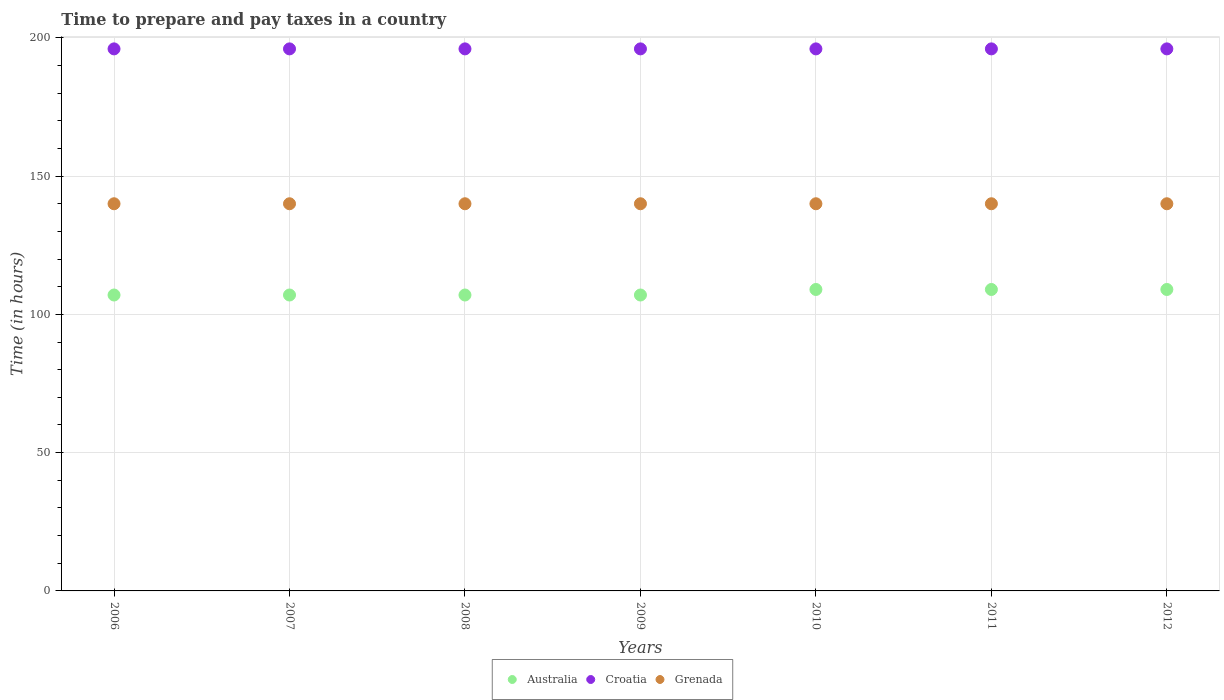How many different coloured dotlines are there?
Your response must be concise. 3. Is the number of dotlines equal to the number of legend labels?
Offer a terse response. Yes. What is the number of hours required to prepare and pay taxes in Australia in 2009?
Offer a terse response. 107. Across all years, what is the maximum number of hours required to prepare and pay taxes in Croatia?
Ensure brevity in your answer.  196. Across all years, what is the minimum number of hours required to prepare and pay taxes in Australia?
Make the answer very short. 107. What is the total number of hours required to prepare and pay taxes in Croatia in the graph?
Your answer should be compact. 1372. What is the difference between the number of hours required to prepare and pay taxes in Grenada in 2006 and that in 2009?
Offer a very short reply. 0. What is the difference between the number of hours required to prepare and pay taxes in Grenada in 2008 and the number of hours required to prepare and pay taxes in Croatia in 2009?
Provide a succinct answer. -56. What is the average number of hours required to prepare and pay taxes in Croatia per year?
Offer a very short reply. 196. In the year 2007, what is the difference between the number of hours required to prepare and pay taxes in Australia and number of hours required to prepare and pay taxes in Grenada?
Provide a succinct answer. -33. What is the ratio of the number of hours required to prepare and pay taxes in Australia in 2010 to that in 2011?
Your response must be concise. 1. Is the number of hours required to prepare and pay taxes in Grenada in 2009 less than that in 2011?
Ensure brevity in your answer.  No. What is the difference between the highest and the second highest number of hours required to prepare and pay taxes in Croatia?
Give a very brief answer. 0. What is the difference between the highest and the lowest number of hours required to prepare and pay taxes in Grenada?
Provide a short and direct response. 0. Does the number of hours required to prepare and pay taxes in Australia monotonically increase over the years?
Your answer should be very brief. No. Is the number of hours required to prepare and pay taxes in Croatia strictly greater than the number of hours required to prepare and pay taxes in Australia over the years?
Your answer should be very brief. Yes. How many years are there in the graph?
Your answer should be compact. 7. What is the difference between two consecutive major ticks on the Y-axis?
Offer a terse response. 50. Does the graph contain any zero values?
Provide a succinct answer. No. How many legend labels are there?
Your answer should be very brief. 3. How are the legend labels stacked?
Provide a succinct answer. Horizontal. What is the title of the graph?
Make the answer very short. Time to prepare and pay taxes in a country. What is the label or title of the Y-axis?
Make the answer very short. Time (in hours). What is the Time (in hours) in Australia in 2006?
Provide a short and direct response. 107. What is the Time (in hours) of Croatia in 2006?
Your answer should be very brief. 196. What is the Time (in hours) in Grenada in 2006?
Offer a terse response. 140. What is the Time (in hours) in Australia in 2007?
Offer a very short reply. 107. What is the Time (in hours) in Croatia in 2007?
Ensure brevity in your answer.  196. What is the Time (in hours) in Grenada in 2007?
Provide a short and direct response. 140. What is the Time (in hours) in Australia in 2008?
Keep it short and to the point. 107. What is the Time (in hours) in Croatia in 2008?
Your answer should be compact. 196. What is the Time (in hours) in Grenada in 2008?
Provide a short and direct response. 140. What is the Time (in hours) in Australia in 2009?
Make the answer very short. 107. What is the Time (in hours) in Croatia in 2009?
Offer a terse response. 196. What is the Time (in hours) of Grenada in 2009?
Give a very brief answer. 140. What is the Time (in hours) in Australia in 2010?
Give a very brief answer. 109. What is the Time (in hours) of Croatia in 2010?
Your response must be concise. 196. What is the Time (in hours) of Grenada in 2010?
Ensure brevity in your answer.  140. What is the Time (in hours) of Australia in 2011?
Provide a short and direct response. 109. What is the Time (in hours) in Croatia in 2011?
Your answer should be compact. 196. What is the Time (in hours) in Grenada in 2011?
Ensure brevity in your answer.  140. What is the Time (in hours) of Australia in 2012?
Your answer should be very brief. 109. What is the Time (in hours) of Croatia in 2012?
Your response must be concise. 196. What is the Time (in hours) of Grenada in 2012?
Provide a succinct answer. 140. Across all years, what is the maximum Time (in hours) of Australia?
Your answer should be compact. 109. Across all years, what is the maximum Time (in hours) of Croatia?
Your answer should be compact. 196. Across all years, what is the maximum Time (in hours) in Grenada?
Your response must be concise. 140. Across all years, what is the minimum Time (in hours) of Australia?
Your answer should be very brief. 107. Across all years, what is the minimum Time (in hours) in Croatia?
Provide a short and direct response. 196. Across all years, what is the minimum Time (in hours) of Grenada?
Your response must be concise. 140. What is the total Time (in hours) in Australia in the graph?
Keep it short and to the point. 755. What is the total Time (in hours) of Croatia in the graph?
Ensure brevity in your answer.  1372. What is the total Time (in hours) in Grenada in the graph?
Keep it short and to the point. 980. What is the difference between the Time (in hours) of Australia in 2006 and that in 2007?
Offer a terse response. 0. What is the difference between the Time (in hours) in Australia in 2006 and that in 2008?
Your answer should be very brief. 0. What is the difference between the Time (in hours) of Grenada in 2006 and that in 2008?
Ensure brevity in your answer.  0. What is the difference between the Time (in hours) of Australia in 2006 and that in 2009?
Give a very brief answer. 0. What is the difference between the Time (in hours) in Croatia in 2006 and that in 2009?
Your answer should be compact. 0. What is the difference between the Time (in hours) in Croatia in 2006 and that in 2010?
Make the answer very short. 0. What is the difference between the Time (in hours) in Grenada in 2006 and that in 2010?
Keep it short and to the point. 0. What is the difference between the Time (in hours) of Croatia in 2006 and that in 2011?
Your response must be concise. 0. What is the difference between the Time (in hours) in Australia in 2006 and that in 2012?
Make the answer very short. -2. What is the difference between the Time (in hours) of Grenada in 2006 and that in 2012?
Keep it short and to the point. 0. What is the difference between the Time (in hours) in Grenada in 2007 and that in 2008?
Your answer should be compact. 0. What is the difference between the Time (in hours) in Australia in 2007 and that in 2009?
Your answer should be compact. 0. What is the difference between the Time (in hours) of Croatia in 2007 and that in 2009?
Give a very brief answer. 0. What is the difference between the Time (in hours) of Grenada in 2007 and that in 2009?
Offer a terse response. 0. What is the difference between the Time (in hours) of Australia in 2007 and that in 2011?
Your answer should be compact. -2. What is the difference between the Time (in hours) in Grenada in 2007 and that in 2011?
Give a very brief answer. 0. What is the difference between the Time (in hours) in Australia in 2007 and that in 2012?
Give a very brief answer. -2. What is the difference between the Time (in hours) in Australia in 2008 and that in 2009?
Provide a short and direct response. 0. What is the difference between the Time (in hours) in Australia in 2008 and that in 2010?
Your answer should be very brief. -2. What is the difference between the Time (in hours) in Grenada in 2008 and that in 2010?
Your response must be concise. 0. What is the difference between the Time (in hours) of Grenada in 2008 and that in 2011?
Provide a succinct answer. 0. What is the difference between the Time (in hours) in Australia in 2008 and that in 2012?
Give a very brief answer. -2. What is the difference between the Time (in hours) in Croatia in 2008 and that in 2012?
Keep it short and to the point. 0. What is the difference between the Time (in hours) in Croatia in 2009 and that in 2010?
Your answer should be compact. 0. What is the difference between the Time (in hours) in Australia in 2009 and that in 2011?
Provide a succinct answer. -2. What is the difference between the Time (in hours) of Croatia in 2009 and that in 2011?
Offer a very short reply. 0. What is the difference between the Time (in hours) of Grenada in 2009 and that in 2011?
Keep it short and to the point. 0. What is the difference between the Time (in hours) in Australia in 2009 and that in 2012?
Ensure brevity in your answer.  -2. What is the difference between the Time (in hours) of Croatia in 2009 and that in 2012?
Offer a very short reply. 0. What is the difference between the Time (in hours) of Grenada in 2009 and that in 2012?
Keep it short and to the point. 0. What is the difference between the Time (in hours) of Croatia in 2010 and that in 2012?
Keep it short and to the point. 0. What is the difference between the Time (in hours) in Grenada in 2010 and that in 2012?
Give a very brief answer. 0. What is the difference between the Time (in hours) in Australia in 2011 and that in 2012?
Make the answer very short. 0. What is the difference between the Time (in hours) of Australia in 2006 and the Time (in hours) of Croatia in 2007?
Your answer should be very brief. -89. What is the difference between the Time (in hours) of Australia in 2006 and the Time (in hours) of Grenada in 2007?
Make the answer very short. -33. What is the difference between the Time (in hours) in Croatia in 2006 and the Time (in hours) in Grenada in 2007?
Your answer should be compact. 56. What is the difference between the Time (in hours) in Australia in 2006 and the Time (in hours) in Croatia in 2008?
Provide a succinct answer. -89. What is the difference between the Time (in hours) in Australia in 2006 and the Time (in hours) in Grenada in 2008?
Keep it short and to the point. -33. What is the difference between the Time (in hours) in Croatia in 2006 and the Time (in hours) in Grenada in 2008?
Your answer should be compact. 56. What is the difference between the Time (in hours) in Australia in 2006 and the Time (in hours) in Croatia in 2009?
Give a very brief answer. -89. What is the difference between the Time (in hours) of Australia in 2006 and the Time (in hours) of Grenada in 2009?
Keep it short and to the point. -33. What is the difference between the Time (in hours) in Australia in 2006 and the Time (in hours) in Croatia in 2010?
Your answer should be very brief. -89. What is the difference between the Time (in hours) of Australia in 2006 and the Time (in hours) of Grenada in 2010?
Your answer should be very brief. -33. What is the difference between the Time (in hours) of Australia in 2006 and the Time (in hours) of Croatia in 2011?
Provide a succinct answer. -89. What is the difference between the Time (in hours) of Australia in 2006 and the Time (in hours) of Grenada in 2011?
Make the answer very short. -33. What is the difference between the Time (in hours) of Croatia in 2006 and the Time (in hours) of Grenada in 2011?
Your answer should be compact. 56. What is the difference between the Time (in hours) of Australia in 2006 and the Time (in hours) of Croatia in 2012?
Your answer should be compact. -89. What is the difference between the Time (in hours) of Australia in 2006 and the Time (in hours) of Grenada in 2012?
Provide a succinct answer. -33. What is the difference between the Time (in hours) of Australia in 2007 and the Time (in hours) of Croatia in 2008?
Offer a very short reply. -89. What is the difference between the Time (in hours) of Australia in 2007 and the Time (in hours) of Grenada in 2008?
Your answer should be very brief. -33. What is the difference between the Time (in hours) in Australia in 2007 and the Time (in hours) in Croatia in 2009?
Make the answer very short. -89. What is the difference between the Time (in hours) of Australia in 2007 and the Time (in hours) of Grenada in 2009?
Offer a very short reply. -33. What is the difference between the Time (in hours) of Australia in 2007 and the Time (in hours) of Croatia in 2010?
Offer a terse response. -89. What is the difference between the Time (in hours) of Australia in 2007 and the Time (in hours) of Grenada in 2010?
Your answer should be very brief. -33. What is the difference between the Time (in hours) of Croatia in 2007 and the Time (in hours) of Grenada in 2010?
Provide a short and direct response. 56. What is the difference between the Time (in hours) in Australia in 2007 and the Time (in hours) in Croatia in 2011?
Make the answer very short. -89. What is the difference between the Time (in hours) of Australia in 2007 and the Time (in hours) of Grenada in 2011?
Provide a short and direct response. -33. What is the difference between the Time (in hours) in Australia in 2007 and the Time (in hours) in Croatia in 2012?
Offer a very short reply. -89. What is the difference between the Time (in hours) of Australia in 2007 and the Time (in hours) of Grenada in 2012?
Offer a terse response. -33. What is the difference between the Time (in hours) of Australia in 2008 and the Time (in hours) of Croatia in 2009?
Make the answer very short. -89. What is the difference between the Time (in hours) in Australia in 2008 and the Time (in hours) in Grenada in 2009?
Your answer should be compact. -33. What is the difference between the Time (in hours) in Croatia in 2008 and the Time (in hours) in Grenada in 2009?
Keep it short and to the point. 56. What is the difference between the Time (in hours) in Australia in 2008 and the Time (in hours) in Croatia in 2010?
Offer a terse response. -89. What is the difference between the Time (in hours) of Australia in 2008 and the Time (in hours) of Grenada in 2010?
Offer a very short reply. -33. What is the difference between the Time (in hours) of Croatia in 2008 and the Time (in hours) of Grenada in 2010?
Give a very brief answer. 56. What is the difference between the Time (in hours) of Australia in 2008 and the Time (in hours) of Croatia in 2011?
Offer a very short reply. -89. What is the difference between the Time (in hours) of Australia in 2008 and the Time (in hours) of Grenada in 2011?
Offer a very short reply. -33. What is the difference between the Time (in hours) of Croatia in 2008 and the Time (in hours) of Grenada in 2011?
Give a very brief answer. 56. What is the difference between the Time (in hours) in Australia in 2008 and the Time (in hours) in Croatia in 2012?
Your answer should be very brief. -89. What is the difference between the Time (in hours) of Australia in 2008 and the Time (in hours) of Grenada in 2012?
Offer a very short reply. -33. What is the difference between the Time (in hours) in Croatia in 2008 and the Time (in hours) in Grenada in 2012?
Provide a short and direct response. 56. What is the difference between the Time (in hours) in Australia in 2009 and the Time (in hours) in Croatia in 2010?
Give a very brief answer. -89. What is the difference between the Time (in hours) in Australia in 2009 and the Time (in hours) in Grenada in 2010?
Your response must be concise. -33. What is the difference between the Time (in hours) of Australia in 2009 and the Time (in hours) of Croatia in 2011?
Provide a succinct answer. -89. What is the difference between the Time (in hours) of Australia in 2009 and the Time (in hours) of Grenada in 2011?
Keep it short and to the point. -33. What is the difference between the Time (in hours) in Croatia in 2009 and the Time (in hours) in Grenada in 2011?
Keep it short and to the point. 56. What is the difference between the Time (in hours) in Australia in 2009 and the Time (in hours) in Croatia in 2012?
Your answer should be very brief. -89. What is the difference between the Time (in hours) of Australia in 2009 and the Time (in hours) of Grenada in 2012?
Provide a short and direct response. -33. What is the difference between the Time (in hours) in Croatia in 2009 and the Time (in hours) in Grenada in 2012?
Your answer should be very brief. 56. What is the difference between the Time (in hours) of Australia in 2010 and the Time (in hours) of Croatia in 2011?
Your answer should be compact. -87. What is the difference between the Time (in hours) of Australia in 2010 and the Time (in hours) of Grenada in 2011?
Give a very brief answer. -31. What is the difference between the Time (in hours) in Australia in 2010 and the Time (in hours) in Croatia in 2012?
Ensure brevity in your answer.  -87. What is the difference between the Time (in hours) of Australia in 2010 and the Time (in hours) of Grenada in 2012?
Your response must be concise. -31. What is the difference between the Time (in hours) of Australia in 2011 and the Time (in hours) of Croatia in 2012?
Your response must be concise. -87. What is the difference between the Time (in hours) in Australia in 2011 and the Time (in hours) in Grenada in 2012?
Offer a very short reply. -31. What is the average Time (in hours) in Australia per year?
Provide a short and direct response. 107.86. What is the average Time (in hours) of Croatia per year?
Offer a very short reply. 196. What is the average Time (in hours) in Grenada per year?
Your answer should be compact. 140. In the year 2006, what is the difference between the Time (in hours) of Australia and Time (in hours) of Croatia?
Offer a terse response. -89. In the year 2006, what is the difference between the Time (in hours) in Australia and Time (in hours) in Grenada?
Ensure brevity in your answer.  -33. In the year 2007, what is the difference between the Time (in hours) of Australia and Time (in hours) of Croatia?
Your response must be concise. -89. In the year 2007, what is the difference between the Time (in hours) of Australia and Time (in hours) of Grenada?
Ensure brevity in your answer.  -33. In the year 2007, what is the difference between the Time (in hours) in Croatia and Time (in hours) in Grenada?
Your response must be concise. 56. In the year 2008, what is the difference between the Time (in hours) of Australia and Time (in hours) of Croatia?
Your answer should be compact. -89. In the year 2008, what is the difference between the Time (in hours) in Australia and Time (in hours) in Grenada?
Provide a succinct answer. -33. In the year 2008, what is the difference between the Time (in hours) of Croatia and Time (in hours) of Grenada?
Keep it short and to the point. 56. In the year 2009, what is the difference between the Time (in hours) of Australia and Time (in hours) of Croatia?
Offer a terse response. -89. In the year 2009, what is the difference between the Time (in hours) of Australia and Time (in hours) of Grenada?
Give a very brief answer. -33. In the year 2009, what is the difference between the Time (in hours) in Croatia and Time (in hours) in Grenada?
Give a very brief answer. 56. In the year 2010, what is the difference between the Time (in hours) of Australia and Time (in hours) of Croatia?
Your answer should be very brief. -87. In the year 2010, what is the difference between the Time (in hours) of Australia and Time (in hours) of Grenada?
Your response must be concise. -31. In the year 2011, what is the difference between the Time (in hours) in Australia and Time (in hours) in Croatia?
Offer a terse response. -87. In the year 2011, what is the difference between the Time (in hours) in Australia and Time (in hours) in Grenada?
Make the answer very short. -31. In the year 2012, what is the difference between the Time (in hours) of Australia and Time (in hours) of Croatia?
Provide a short and direct response. -87. In the year 2012, what is the difference between the Time (in hours) of Australia and Time (in hours) of Grenada?
Offer a terse response. -31. In the year 2012, what is the difference between the Time (in hours) in Croatia and Time (in hours) in Grenada?
Keep it short and to the point. 56. What is the ratio of the Time (in hours) of Australia in 2006 to that in 2007?
Keep it short and to the point. 1. What is the ratio of the Time (in hours) in Grenada in 2006 to that in 2007?
Provide a succinct answer. 1. What is the ratio of the Time (in hours) in Australia in 2006 to that in 2008?
Ensure brevity in your answer.  1. What is the ratio of the Time (in hours) of Grenada in 2006 to that in 2008?
Keep it short and to the point. 1. What is the ratio of the Time (in hours) in Croatia in 2006 to that in 2009?
Offer a very short reply. 1. What is the ratio of the Time (in hours) in Grenada in 2006 to that in 2009?
Your answer should be very brief. 1. What is the ratio of the Time (in hours) in Australia in 2006 to that in 2010?
Offer a very short reply. 0.98. What is the ratio of the Time (in hours) in Croatia in 2006 to that in 2010?
Ensure brevity in your answer.  1. What is the ratio of the Time (in hours) in Grenada in 2006 to that in 2010?
Provide a short and direct response. 1. What is the ratio of the Time (in hours) of Australia in 2006 to that in 2011?
Your answer should be compact. 0.98. What is the ratio of the Time (in hours) of Grenada in 2006 to that in 2011?
Provide a succinct answer. 1. What is the ratio of the Time (in hours) in Australia in 2006 to that in 2012?
Offer a very short reply. 0.98. What is the ratio of the Time (in hours) of Croatia in 2006 to that in 2012?
Provide a succinct answer. 1. What is the ratio of the Time (in hours) in Grenada in 2006 to that in 2012?
Offer a terse response. 1. What is the ratio of the Time (in hours) in Croatia in 2007 to that in 2008?
Give a very brief answer. 1. What is the ratio of the Time (in hours) of Croatia in 2007 to that in 2009?
Your answer should be very brief. 1. What is the ratio of the Time (in hours) in Australia in 2007 to that in 2010?
Offer a very short reply. 0.98. What is the ratio of the Time (in hours) of Croatia in 2007 to that in 2010?
Keep it short and to the point. 1. What is the ratio of the Time (in hours) in Grenada in 2007 to that in 2010?
Offer a terse response. 1. What is the ratio of the Time (in hours) in Australia in 2007 to that in 2011?
Provide a short and direct response. 0.98. What is the ratio of the Time (in hours) in Croatia in 2007 to that in 2011?
Keep it short and to the point. 1. What is the ratio of the Time (in hours) in Australia in 2007 to that in 2012?
Provide a short and direct response. 0.98. What is the ratio of the Time (in hours) of Croatia in 2007 to that in 2012?
Your response must be concise. 1. What is the ratio of the Time (in hours) of Australia in 2008 to that in 2009?
Give a very brief answer. 1. What is the ratio of the Time (in hours) of Croatia in 2008 to that in 2009?
Offer a very short reply. 1. What is the ratio of the Time (in hours) in Grenada in 2008 to that in 2009?
Provide a succinct answer. 1. What is the ratio of the Time (in hours) in Australia in 2008 to that in 2010?
Provide a short and direct response. 0.98. What is the ratio of the Time (in hours) in Grenada in 2008 to that in 2010?
Give a very brief answer. 1. What is the ratio of the Time (in hours) in Australia in 2008 to that in 2011?
Give a very brief answer. 0.98. What is the ratio of the Time (in hours) in Grenada in 2008 to that in 2011?
Offer a very short reply. 1. What is the ratio of the Time (in hours) in Australia in 2008 to that in 2012?
Keep it short and to the point. 0.98. What is the ratio of the Time (in hours) in Croatia in 2008 to that in 2012?
Make the answer very short. 1. What is the ratio of the Time (in hours) in Grenada in 2008 to that in 2012?
Keep it short and to the point. 1. What is the ratio of the Time (in hours) of Australia in 2009 to that in 2010?
Give a very brief answer. 0.98. What is the ratio of the Time (in hours) in Croatia in 2009 to that in 2010?
Provide a short and direct response. 1. What is the ratio of the Time (in hours) of Australia in 2009 to that in 2011?
Offer a terse response. 0.98. What is the ratio of the Time (in hours) of Croatia in 2009 to that in 2011?
Provide a short and direct response. 1. What is the ratio of the Time (in hours) in Grenada in 2009 to that in 2011?
Your answer should be compact. 1. What is the ratio of the Time (in hours) of Australia in 2009 to that in 2012?
Your response must be concise. 0.98. What is the ratio of the Time (in hours) in Grenada in 2009 to that in 2012?
Make the answer very short. 1. What is the ratio of the Time (in hours) in Australia in 2010 to that in 2011?
Provide a short and direct response. 1. What is the ratio of the Time (in hours) in Croatia in 2010 to that in 2012?
Give a very brief answer. 1. What is the ratio of the Time (in hours) of Croatia in 2011 to that in 2012?
Your response must be concise. 1. What is the difference between the highest and the second highest Time (in hours) of Australia?
Your answer should be very brief. 0. What is the difference between the highest and the second highest Time (in hours) in Croatia?
Give a very brief answer. 0. What is the difference between the highest and the second highest Time (in hours) of Grenada?
Make the answer very short. 0. What is the difference between the highest and the lowest Time (in hours) in Australia?
Your response must be concise. 2. What is the difference between the highest and the lowest Time (in hours) in Croatia?
Offer a terse response. 0. What is the difference between the highest and the lowest Time (in hours) of Grenada?
Offer a terse response. 0. 